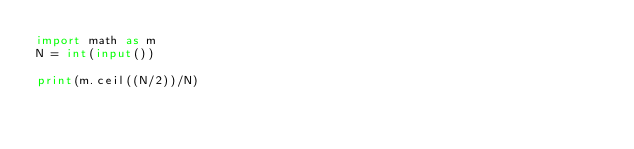Convert code to text. <code><loc_0><loc_0><loc_500><loc_500><_Python_>import math as m
N = int(input())

print(m.ceil((N/2))/N)</code> 